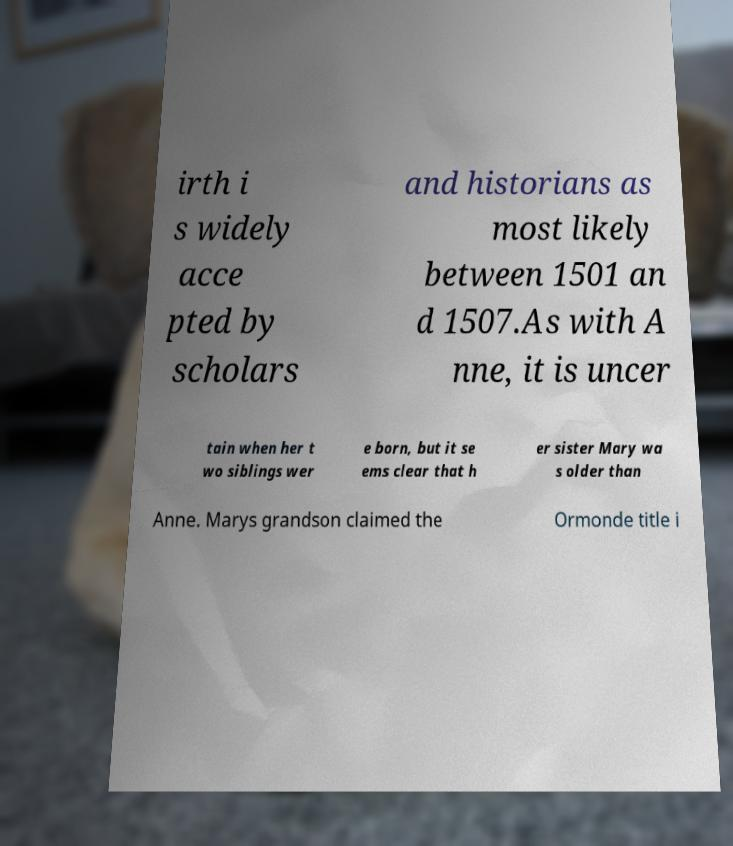Can you read and provide the text displayed in the image?This photo seems to have some interesting text. Can you extract and type it out for me? irth i s widely acce pted by scholars and historians as most likely between 1501 an d 1507.As with A nne, it is uncer tain when her t wo siblings wer e born, but it se ems clear that h er sister Mary wa s older than Anne. Marys grandson claimed the Ormonde title i 